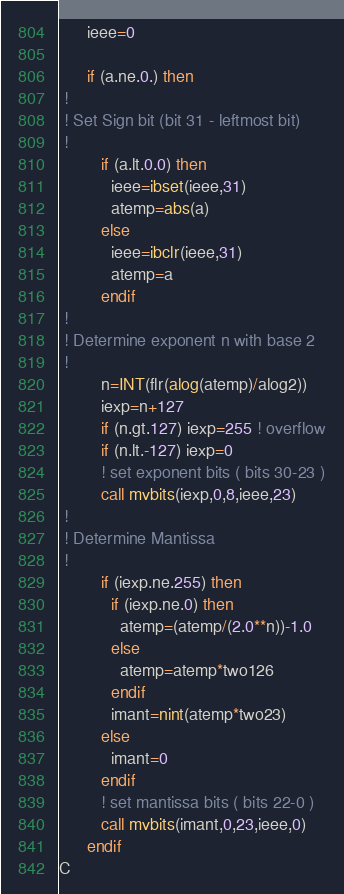<code> <loc_0><loc_0><loc_500><loc_500><_FORTRAN_>      ieee=0

      if (a.ne.0.) then
 !
 ! Set Sign bit (bit 31 - leftmost bit)
 !
         if (a.lt.0.0) then
           ieee=ibset(ieee,31)
           atemp=abs(a)
         else
           ieee=ibclr(ieee,31)
           atemp=a
         endif
 !
 ! Determine exponent n with base 2
 !
         n=INT(flr(alog(atemp)/alog2))
         iexp=n+127
         if (n.gt.127) iexp=255 ! overflow
         if (n.lt.-127) iexp=0
         ! set exponent bits ( bits 30-23 )
         call mvbits(iexp,0,8,ieee,23)
 !
 ! Determine Mantissa
 ! 
         if (iexp.ne.255) then
           if (iexp.ne.0) then
             atemp=(atemp/(2.0**n))-1.0
           else
             atemp=atemp*two126
           endif
           imant=nint(atemp*two23)
         else
           imant=0
         endif
         ! set mantissa bits ( bits 22-0 )
         call mvbits(imant,0,23,ieee,0)
      endif
C</code> 